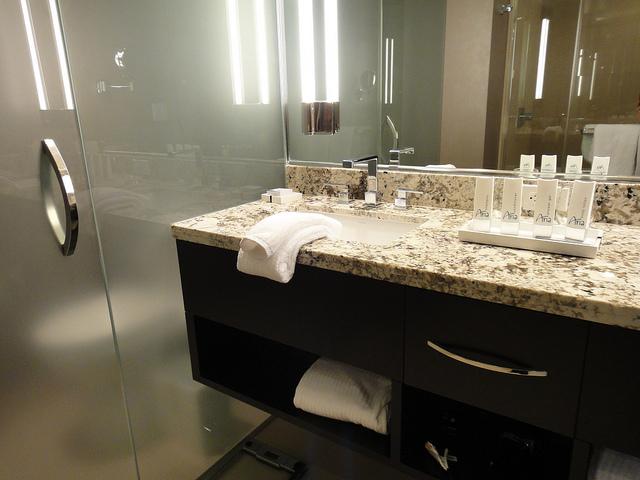Is there a towel on the sink?
Give a very brief answer. Yes. Is the toilet behind the glass wall?
Give a very brief answer. Yes. Is there a person reflected in the mirror?
Keep it brief. No. 